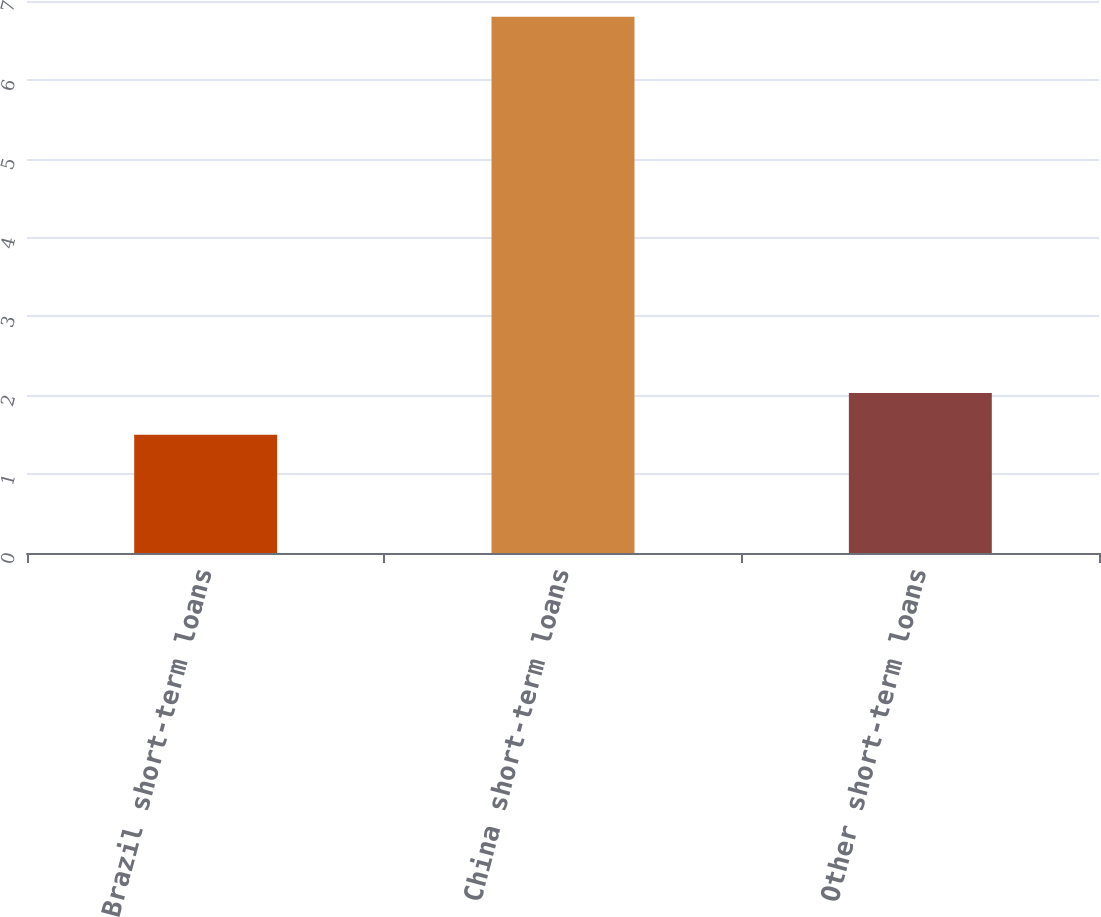Convert chart to OTSL. <chart><loc_0><loc_0><loc_500><loc_500><bar_chart><fcel>Brazil short-term loans<fcel>China short-term loans<fcel>Other short-term loans<nl><fcel>1.5<fcel>6.8<fcel>2.03<nl></chart> 